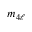Convert formula to latex. <formula><loc_0><loc_0><loc_500><loc_500>m _ { 4 \ell }</formula> 